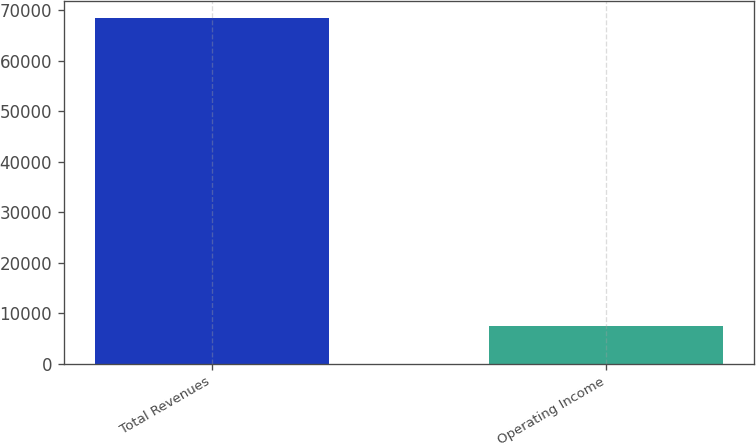<chart> <loc_0><loc_0><loc_500><loc_500><bar_chart><fcel>Total Revenues<fcel>Operating Income<nl><fcel>68483<fcel>7500<nl></chart> 